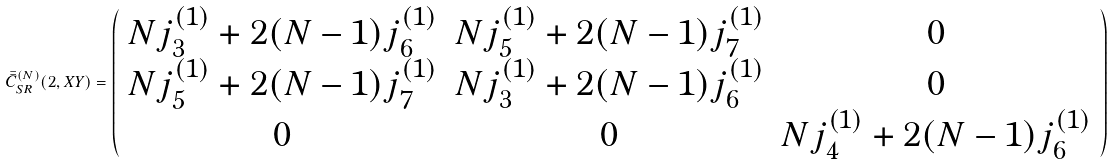Convert formula to latex. <formula><loc_0><loc_0><loc_500><loc_500>\bar { \bar { C } } _ { S R } ^ { ( N ) } ( 2 , X Y ) = \left ( \begin{array} { c c c } N j _ { 3 } ^ { ( 1 ) } + 2 ( N - 1 ) j _ { 6 } ^ { ( 1 ) } & N j _ { 5 } ^ { ( 1 ) } + 2 ( N - 1 ) j _ { 7 } ^ { ( 1 ) } & 0 \\ N j _ { 5 } ^ { ( 1 ) } + 2 ( N - 1 ) j _ { 7 } ^ { ( 1 ) } & N j _ { 3 } ^ { ( 1 ) } + 2 ( N - 1 ) j _ { 6 } ^ { ( 1 ) } & 0 \\ 0 & 0 & N j _ { 4 } ^ { ( 1 ) } + 2 ( N - 1 ) j _ { 6 } ^ { ( 1 ) } \end{array} \right )</formula> 